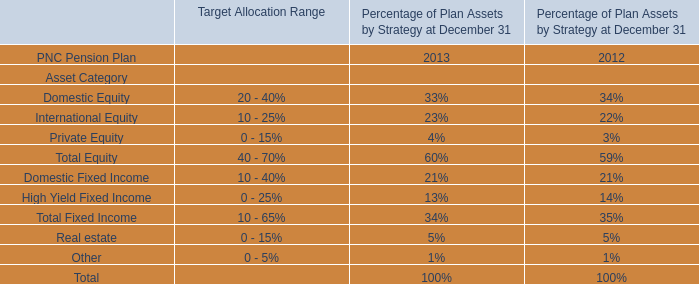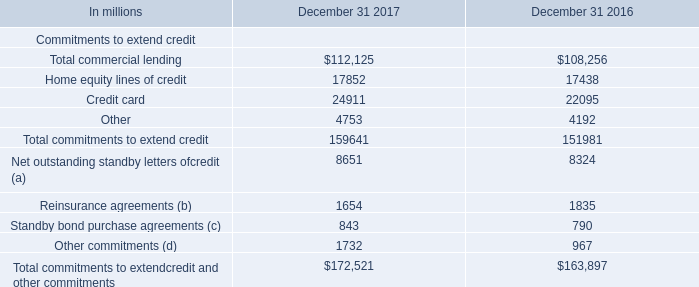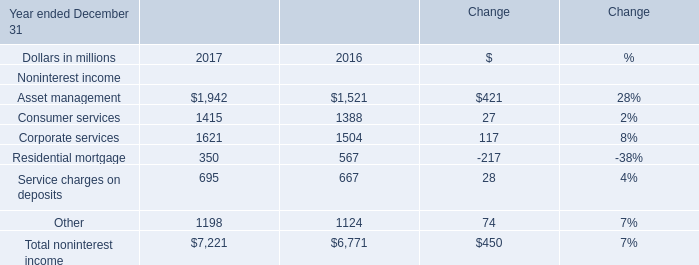what was the change in the total commitments to extend credit from 2016 top 2017 
Computations: ((159641 - 151981) / 151981)
Answer: 0.0504. 